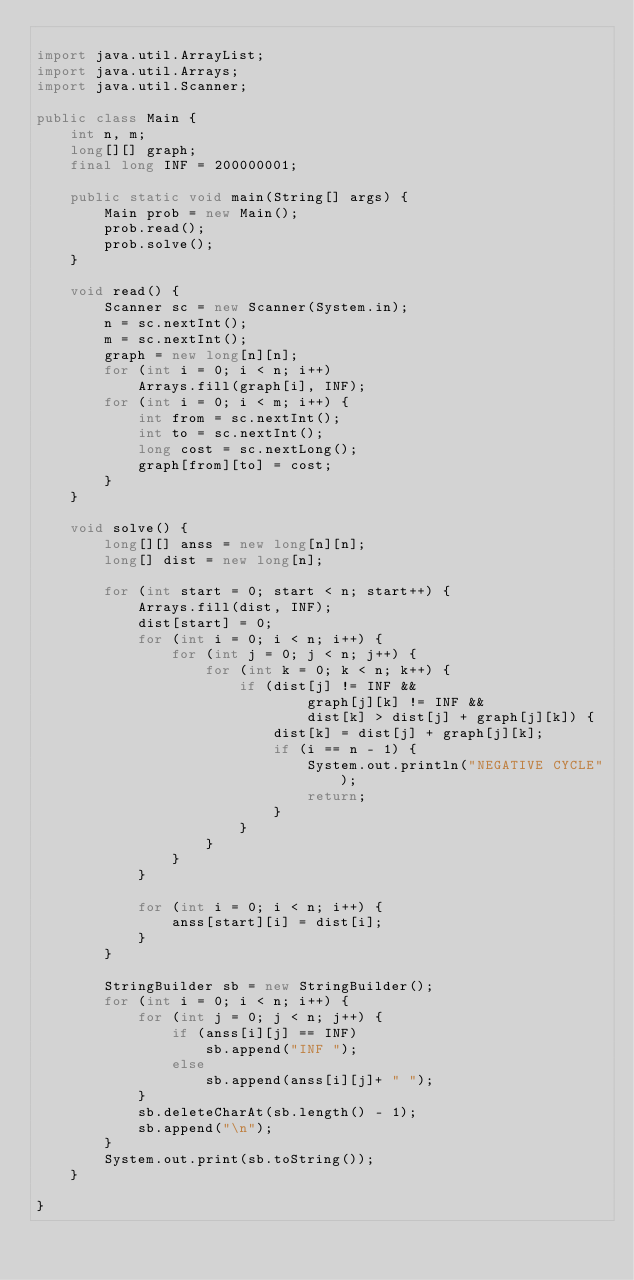Convert code to text. <code><loc_0><loc_0><loc_500><loc_500><_Java_>
import java.util.ArrayList;
import java.util.Arrays;
import java.util.Scanner;

public class Main {
    int n, m;
    long[][] graph;
    final long INF = 200000001;

    public static void main(String[] args) {
        Main prob = new Main();
        prob.read();
        prob.solve();
    }

    void read() {
        Scanner sc = new Scanner(System.in);
        n = sc.nextInt();
        m = sc.nextInt();
        graph = new long[n][n];
        for (int i = 0; i < n; i++)
            Arrays.fill(graph[i], INF);
        for (int i = 0; i < m; i++) {
            int from = sc.nextInt();
            int to = sc.nextInt();
            long cost = sc.nextLong();
            graph[from][to] = cost;
        }
    }

    void solve() {
        long[][] anss = new long[n][n];
        long[] dist = new long[n];

        for (int start = 0; start < n; start++) {
            Arrays.fill(dist, INF);
            dist[start] = 0;
            for (int i = 0; i < n; i++) {
                for (int j = 0; j < n; j++) {
                    for (int k = 0; k < n; k++) {
                        if (dist[j] != INF &&
                                graph[j][k] != INF &&
                                dist[k] > dist[j] + graph[j][k]) {
                            dist[k] = dist[j] + graph[j][k];
                            if (i == n - 1) {
                                System.out.println("NEGATIVE CYCLE");
                                return;
                            }
                        }
                    }
                }
            }

            for (int i = 0; i < n; i++) {
                anss[start][i] = dist[i];
            }
        }

        StringBuilder sb = new StringBuilder();
        for (int i = 0; i < n; i++) {
            for (int j = 0; j < n; j++) {
                if (anss[i][j] == INF)
                    sb.append("INF ");
                else
                    sb.append(anss[i][j]+ " ");
            }
            sb.deleteCharAt(sb.length() - 1);
            sb.append("\n");
        }
        System.out.print(sb.toString());
    }

}</code> 